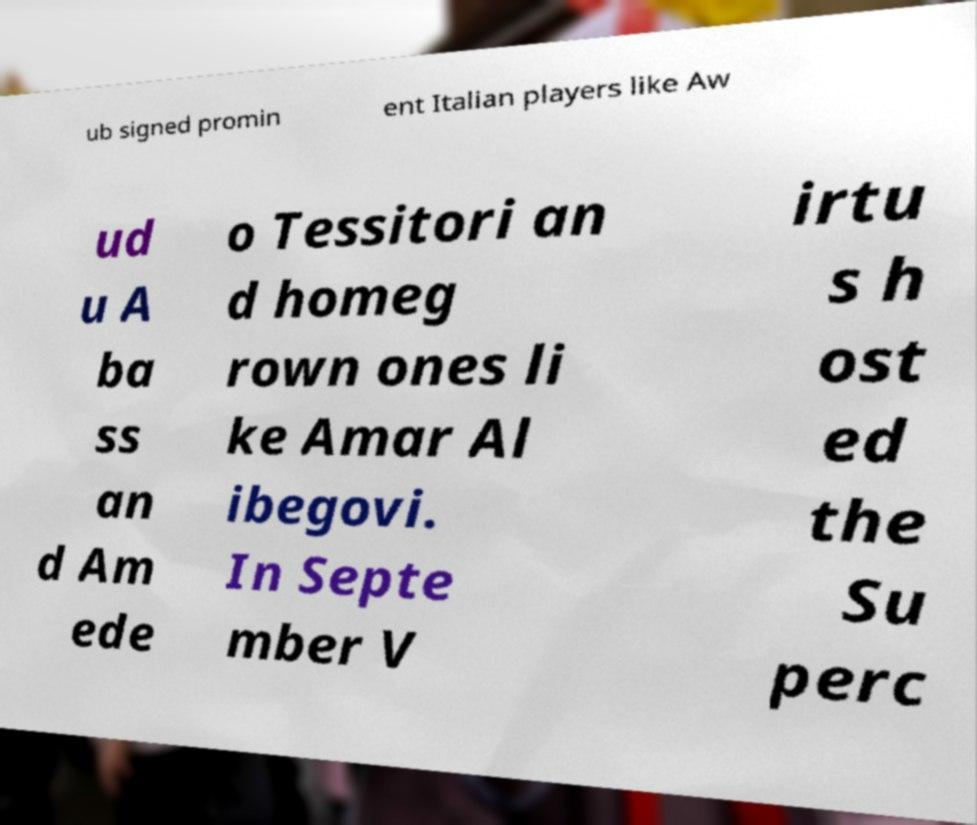Could you extract and type out the text from this image? ub signed promin ent Italian players like Aw ud u A ba ss an d Am ede o Tessitori an d homeg rown ones li ke Amar Al ibegovi. In Septe mber V irtu s h ost ed the Su perc 